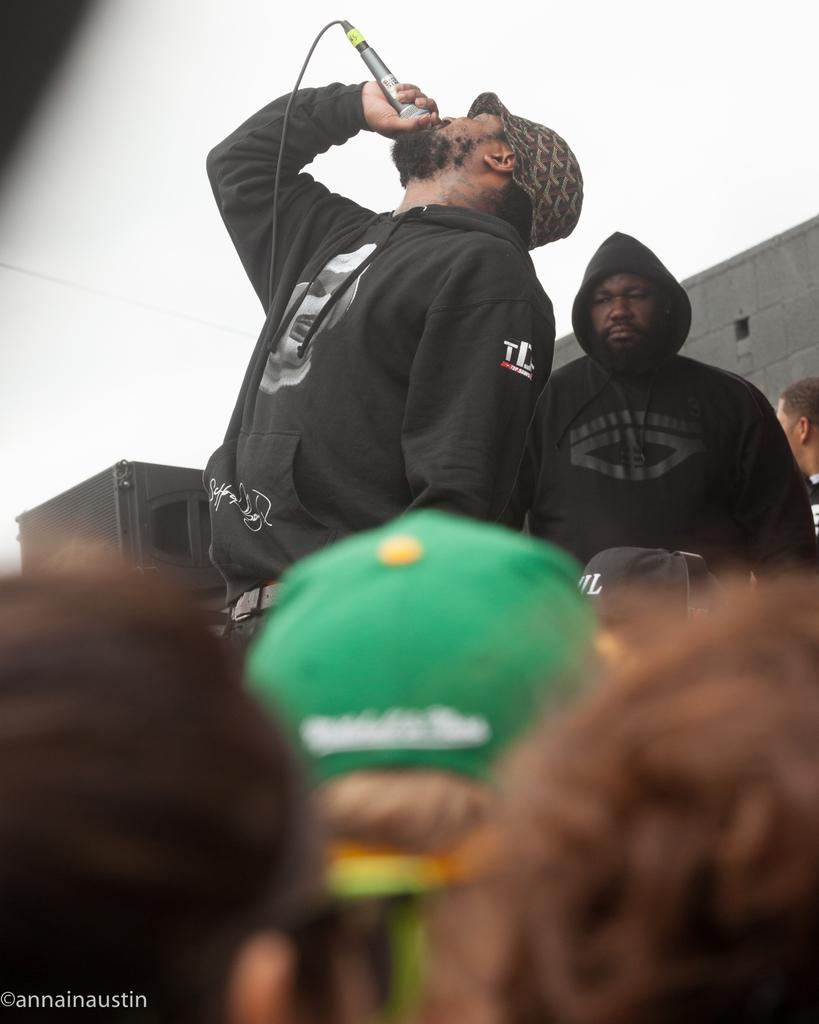How many people are in the image? There are people in the image. What is one person doing in the image? One person is holding a mic. What is the person holding the mic doing? The person holding the mic is singing. What can be seen in the background of the image? There is a wall visible in the image. What is visible above the wall in the image? The sky is visible in the image. What type of representative is sitting on the wall in the image? There is no representative sitting on the wall in the image; the wall is a part of the background. 